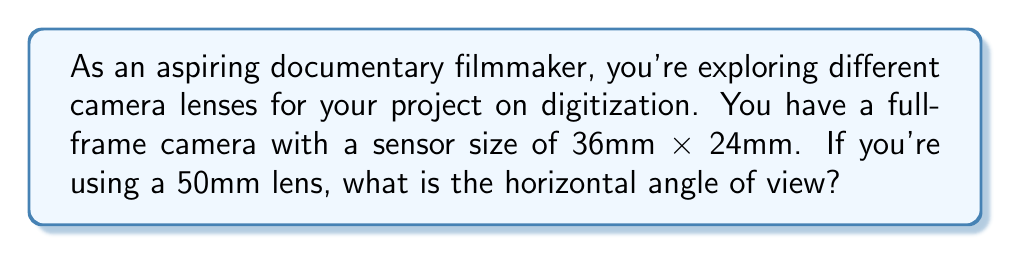Give your solution to this math problem. To solve this problem, we'll use the formula for the angle of view:

$$\text{Angle of View} = 2 \arctan\left(\frac{\text{sensor dimension}}{2f}\right)$$

Where:
- $f$ is the focal length of the lens
- We use the horizontal sensor dimension for horizontal angle of view

Step 1: Identify the known values
- Focal length, $f = 50\text{ mm}$
- Horizontal sensor dimension = 36 mm

Step 2: Plug these values into the formula
$$\text{Horizontal Angle of View} = 2 \arctan\left(\frac{36}{2 \cdot 50}\right)$$

Step 3: Simplify inside the parentheses
$$\text{Horizontal Angle of View} = 2 \arctan\left(\frac{18}{50}\right)$$

Step 4: Calculate the arctangent
$$\text{Horizontal Angle of View} = 2 \cdot 0.3479$$

Step 5: Multiply by 2 and convert to degrees
$$\text{Horizontal Angle of View} = 0.6958 \text{ radians} = 39.6^\circ$$

Therefore, the horizontal angle of view for a 50mm lens on your full-frame camera is approximately 39.6°.
Answer: $39.6^\circ$ 